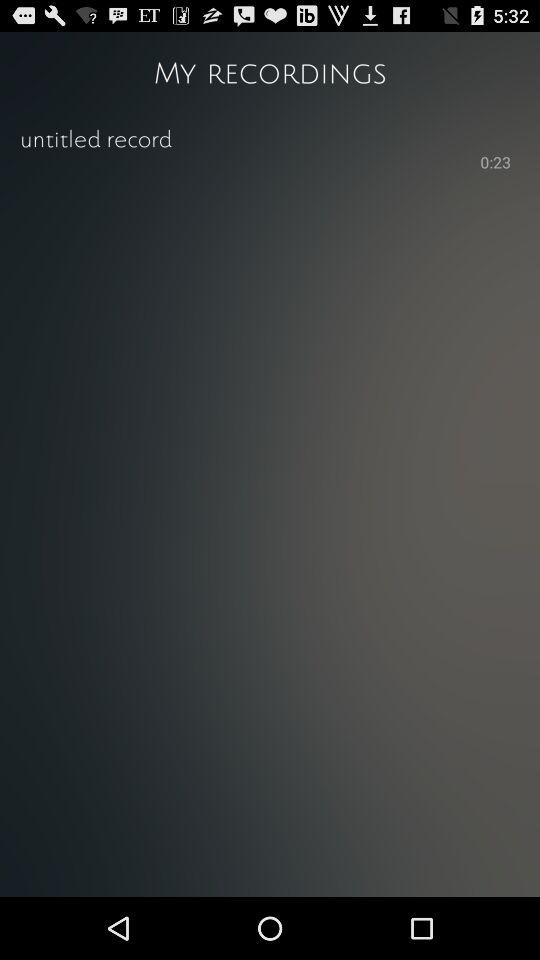How long is the recording?
Answer the question using a single word or phrase. 0:23 